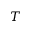Convert formula to latex. <formula><loc_0><loc_0><loc_500><loc_500>T</formula> 